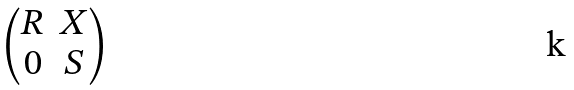Convert formula to latex. <formula><loc_0><loc_0><loc_500><loc_500>\begin{pmatrix} R & X \\ 0 & S \end{pmatrix}</formula> 